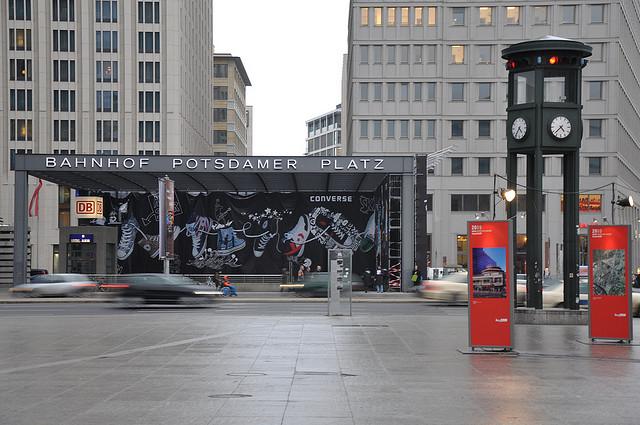Is this location in America?
Quick response, please. No. Is it night time?
Write a very short answer. No. How many clocks are in the picture?
Quick response, please. 2. How many red stands?
Answer briefly. 2. 